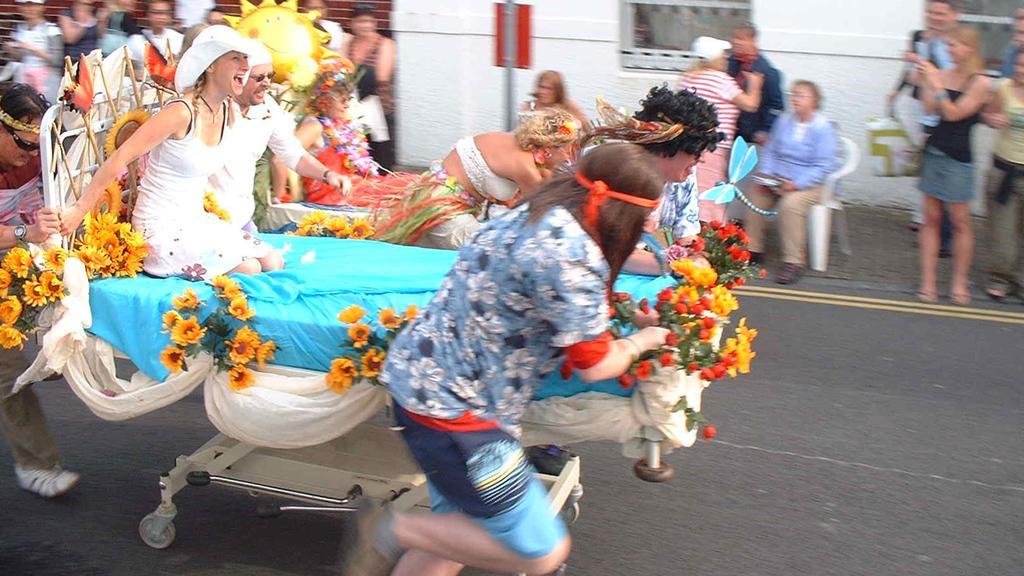Please provide a concise description of this image. In the background we can see the wall, pole and a red board. We can see a person sitting on a chair. We can see people standing. In this picture we can see people sitting on a trolley, which is decorated beautifully with colorful flowers and clothes. On either side of the trolley we can see people. At the bottom we can see the road and wheels of the trolley. 